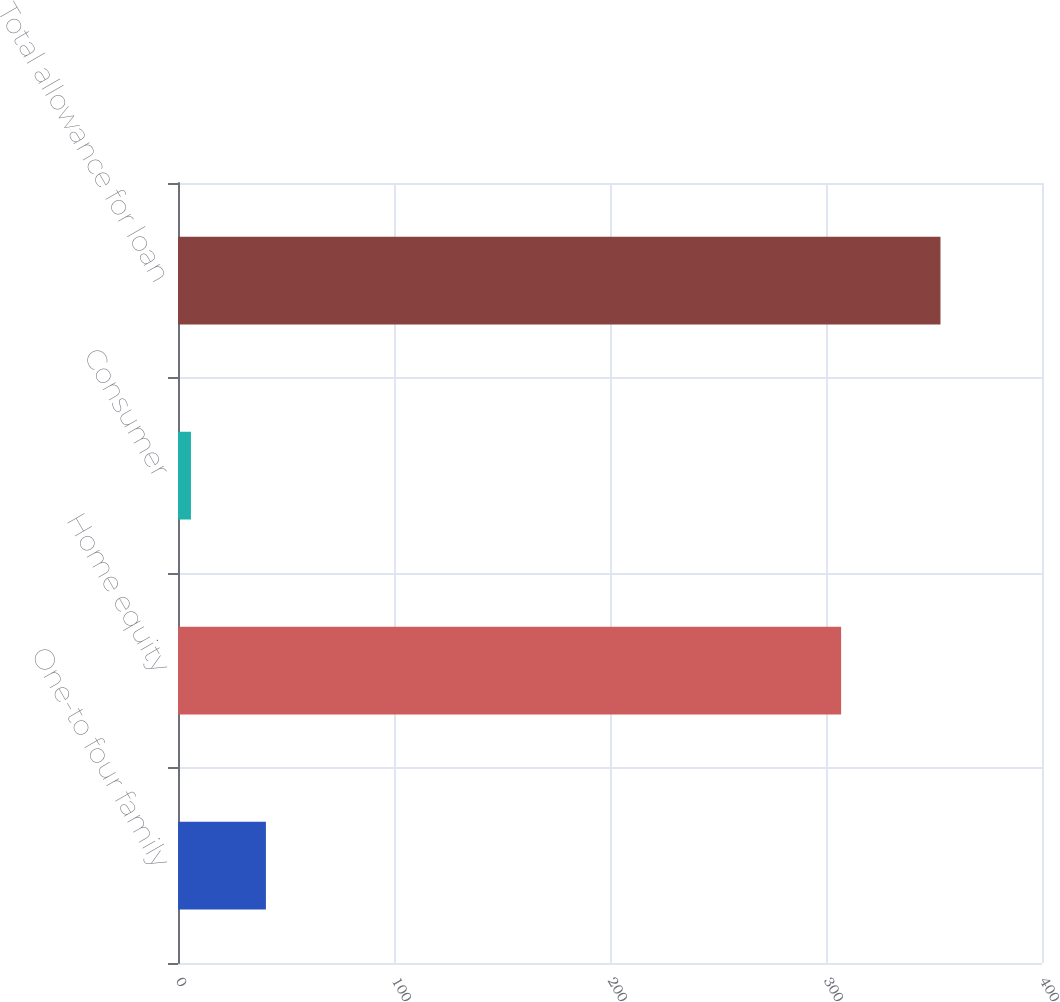Convert chart to OTSL. <chart><loc_0><loc_0><loc_500><loc_500><bar_chart><fcel>One-to four family<fcel>Home equity<fcel>Consumer<fcel>Total allowance for loan<nl><fcel>40.7<fcel>307<fcel>6<fcel>353<nl></chart> 